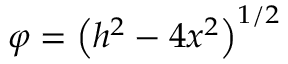<formula> <loc_0><loc_0><loc_500><loc_500>\varphi = \left ( h ^ { 2 } - 4 x ^ { 2 } \right ) ^ { 1 / 2 }</formula> 